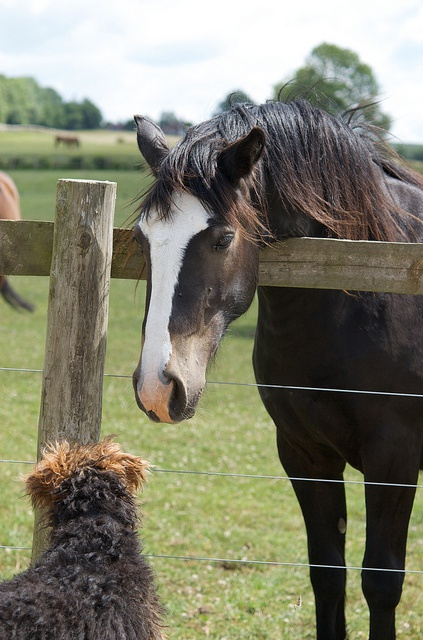Describe the objects in this image and their specific colors. I can see horse in white, black, gray, darkgray, and lightgray tones, dog in white, black, gray, and tan tones, horse in white, tan, gray, and black tones, and horse in white, olive, and gray tones in this image. 